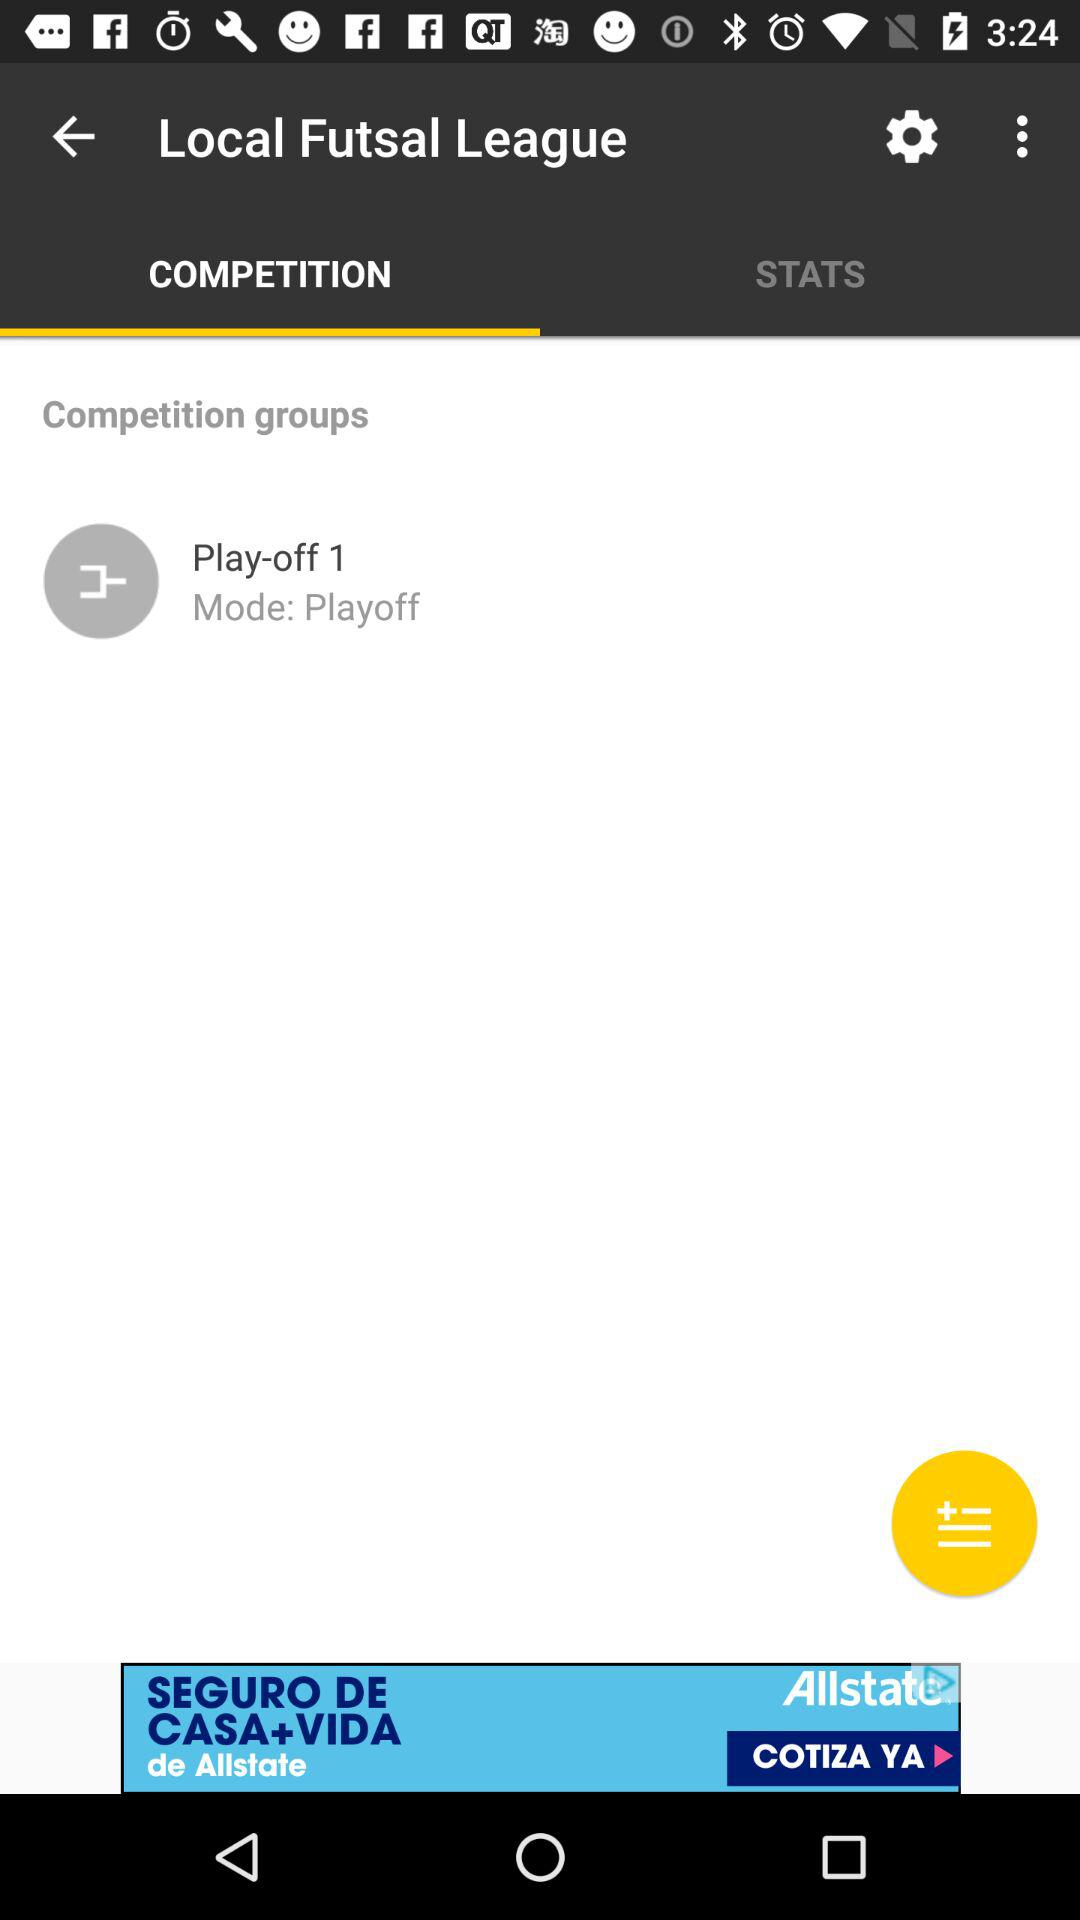Which stats are available for viewing?
When the provided information is insufficient, respond with <no answer>. <no answer> 